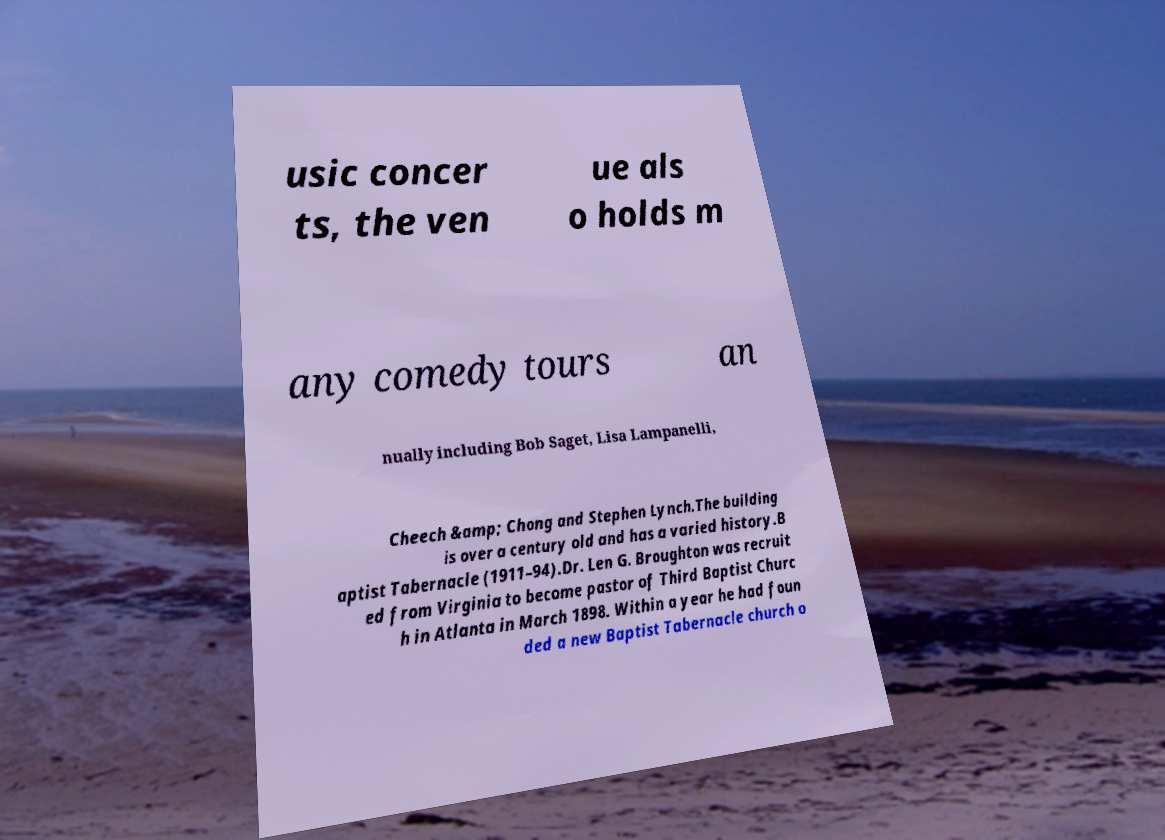Could you extract and type out the text from this image? usic concer ts, the ven ue als o holds m any comedy tours an nually including Bob Saget, Lisa Lampanelli, Cheech &amp; Chong and Stephen Lynch.The building is over a century old and has a varied history.B aptist Tabernacle (1911–94).Dr. Len G. Broughton was recruit ed from Virginia to become pastor of Third Baptist Churc h in Atlanta in March 1898. Within a year he had foun ded a new Baptist Tabernacle church o 